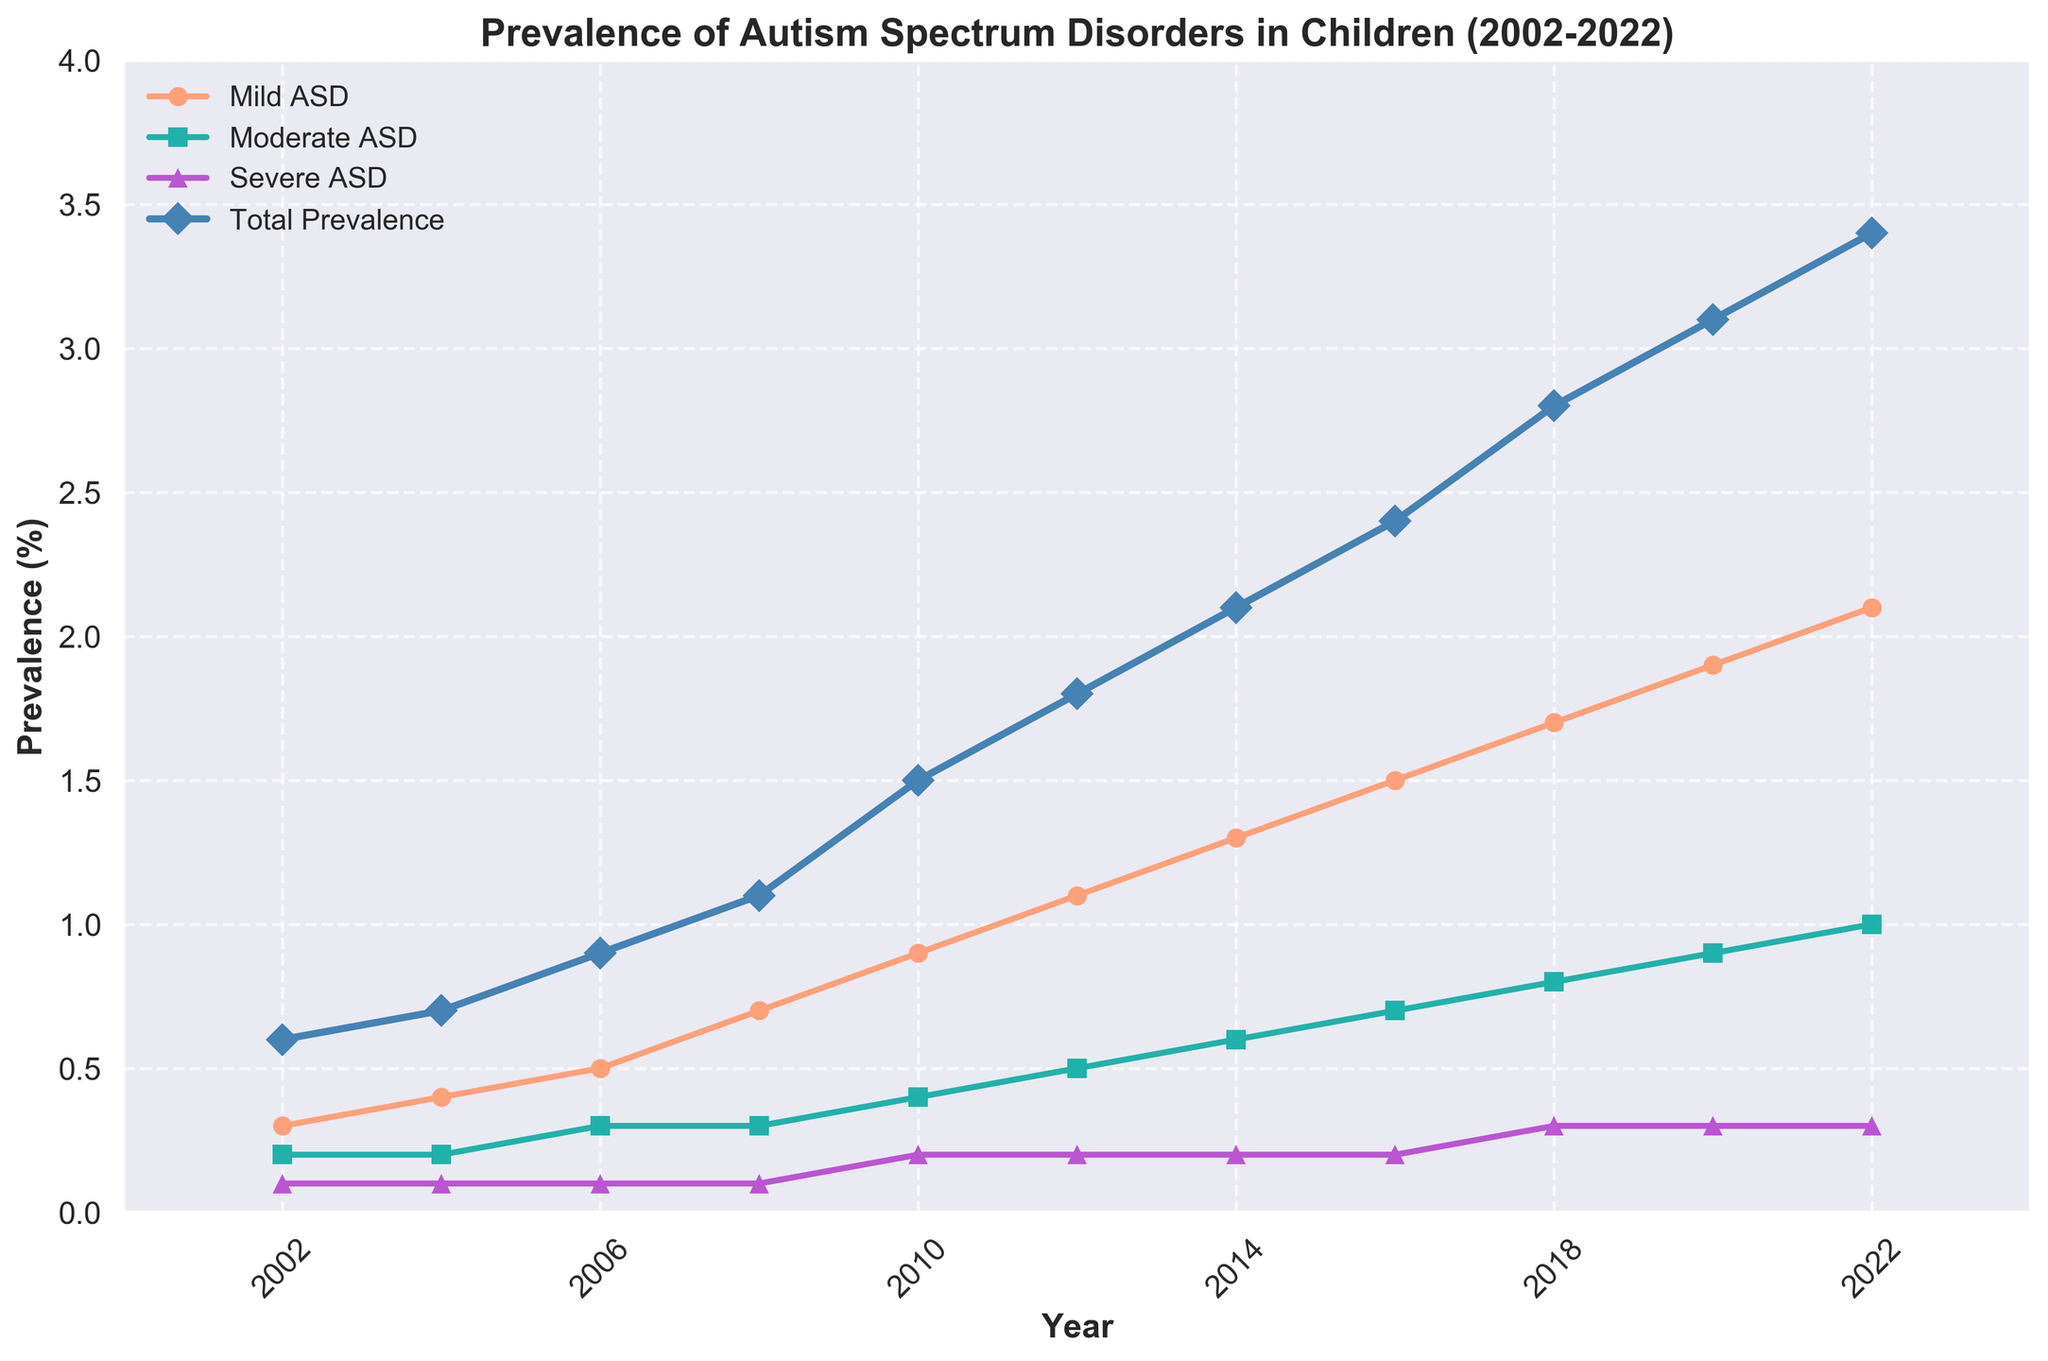Which year shows the highest prevalence of Mild ASD? The line labeled 'Mild ASD' reaches its peak at the year with the highest value. Find the highest point on the Mild ASD line.
Answer: 2022 How many years from 2002 to 2022 did the Total Prevalence remain below 2%? Count the years' markers on the 'Total Prevalence' line that are below the 2% line. These are the years 2002, 2004, 2006, 2008, and 2012. Calculate the number of these years.
Answer: 6 years Which level of ASD had the least change over the years? Compare the lines' slopes. The line with the least change will be the flattest.
Answer: Severe ASD What is the difference in prevalence of Total ASD between 2010 and 2020? On the Total Prevalence line, identify the values at 2010 and 2020. Subtract the 2010 value from the 2020 value.
Answer: 3.1 - 1.5 = 1.6 Comparing 2006 and 2012, which category of ASD showed the greatest absolute increase in prevalence? Find the changes in prevalence for each category: Mild, Moderate, Severe, from 2006 to 2012. For Mild ASD: 1.1 - 0.5 = 0.6; for Moderate ASD: 0.5 - 0.3 = 0.2; for Severe ASD: 0.2 - 0.1 = 0.1. The greatest increase is for Mild ASD.
Answer: Mild ASD During which interval did Total Prevalence increase most rapidly? Look at the Total Prevalence line and identify the steepest segment. Calculate the differences in prevalence for each interval and identify the largest increase.
Answer: 2008 to 2010 How much was the increase in the prevalence of Moderate ASD from 2002 to 2012? Find the Moderate ASD values for 2002 and 2012 from the Moderate ASD line. Subtract the 2002 value from the 2012 value.
Answer: 0.5 - 0.2 = 0.3 Between 2008 and 2020, did the prevalence of Severe ASD change at all? Compare the values on the Severe ASD line at 2008 and 2020. If they are the same, it did not change. The values are 0.3 for both years.
Answer: No What is the combined prevalence of Moderate and Severe ASD in 2004? Add the values of Moderate ASD and Severe ASD from 2004.
Answer: 0.2 + 0.1 = 0.3 